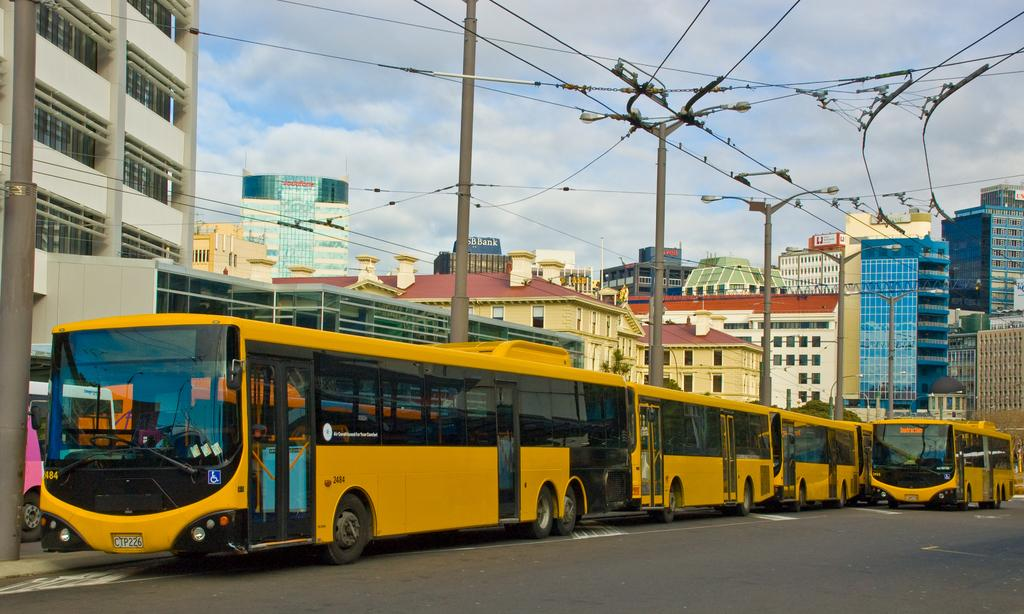What is the main feature of the image? There is a road in the image. What type of vehicles can be seen on the road? There are yellow and black buses on the road. What else is present in the image besides the road and buses? There are poles, wires, buildings, and the sky is visible in the background of the image. How many tickets are hanging from the poles in the image? There are no tickets hanging from the poles in the image. What type of ornament can be seen on top of the buildings in the image? There is no ornament visible on top of the buildings in the image. 